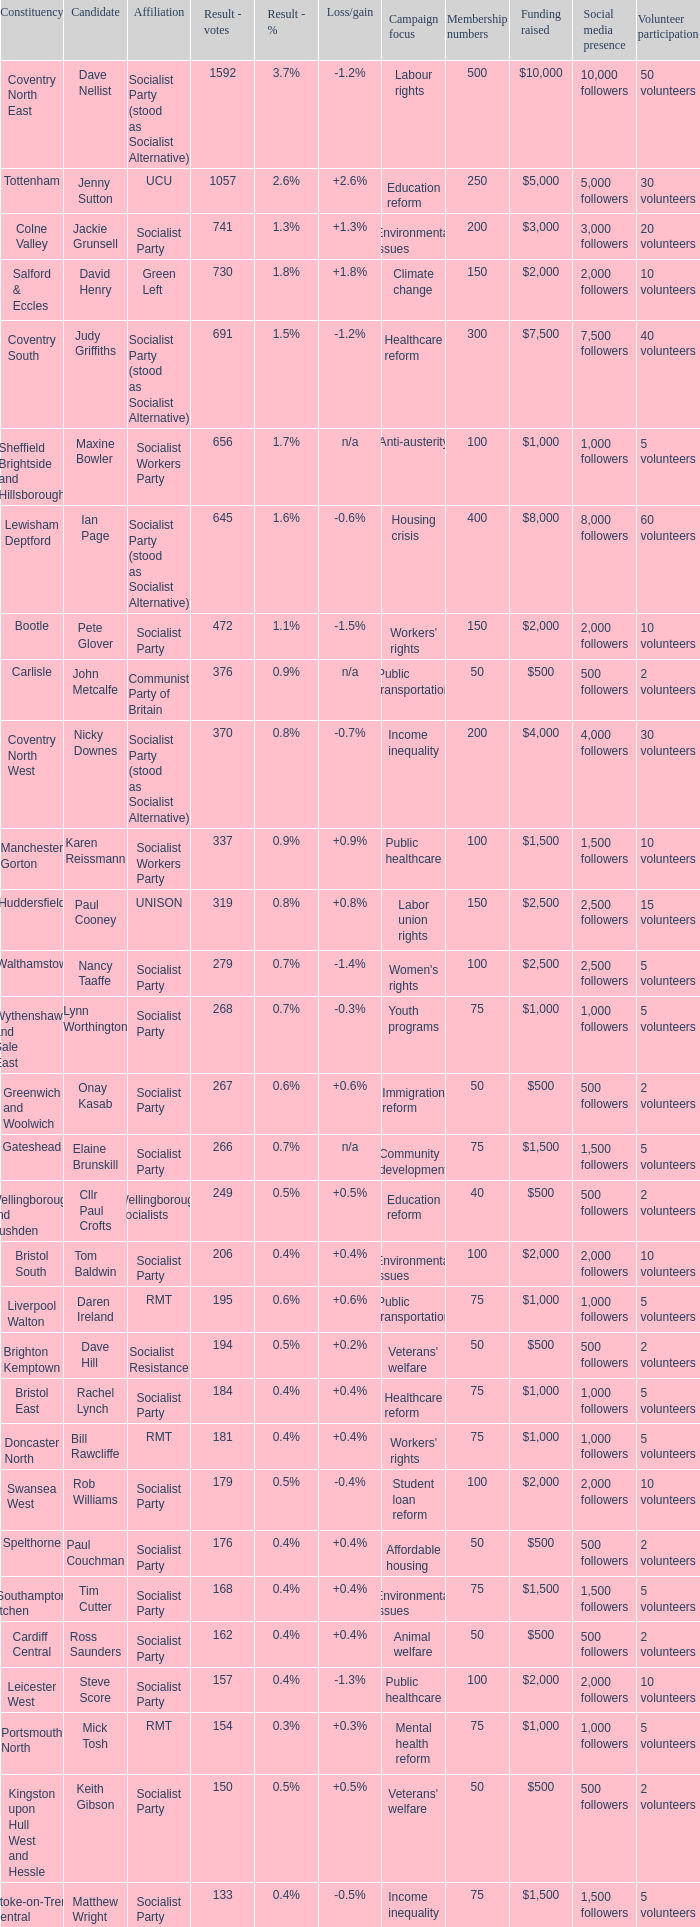Who are all the candidates running for the cardiff central constituency? Ross Saunders. 